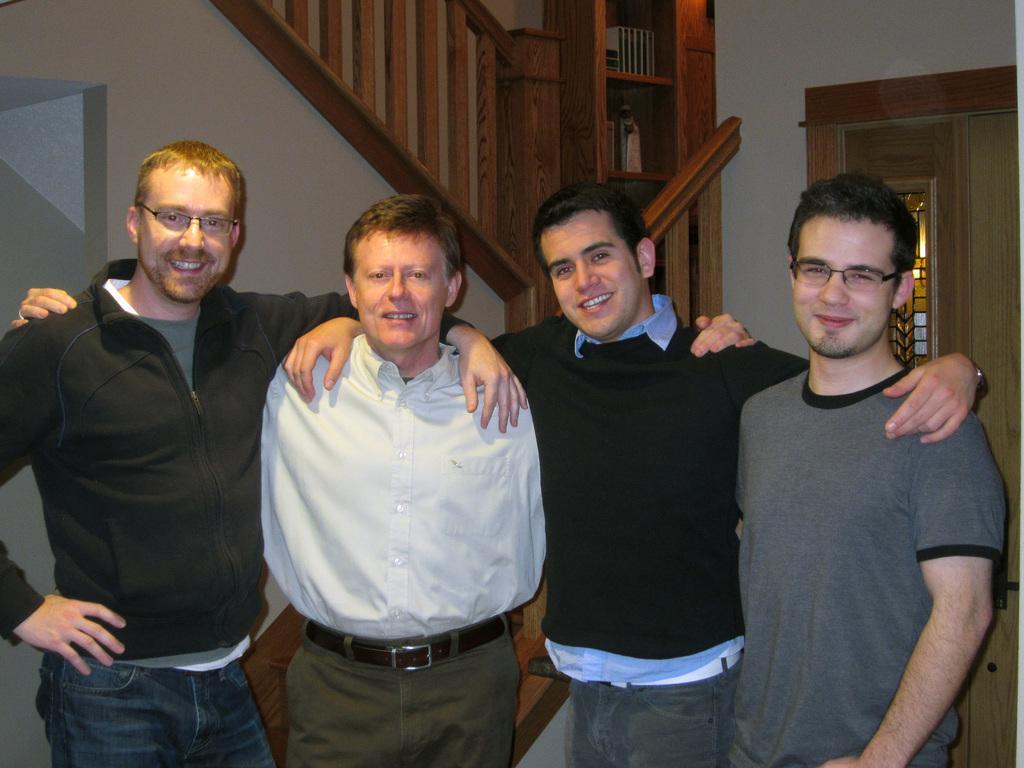In one or two sentences, can you explain what this image depicts? In this picture there is a group for men standing, smiling and giving a pose into the camera. Behind there is a wooden railing and a door. 